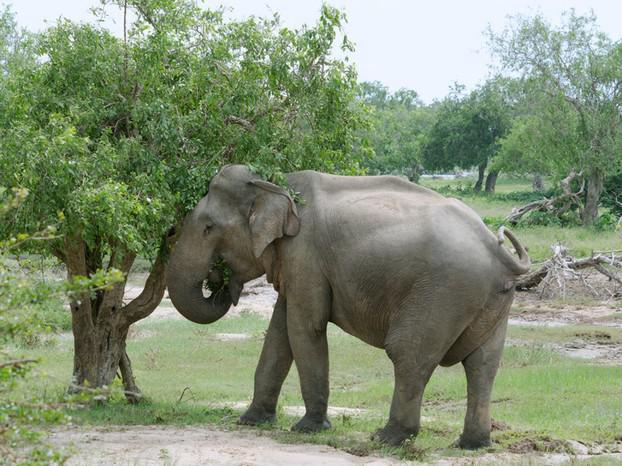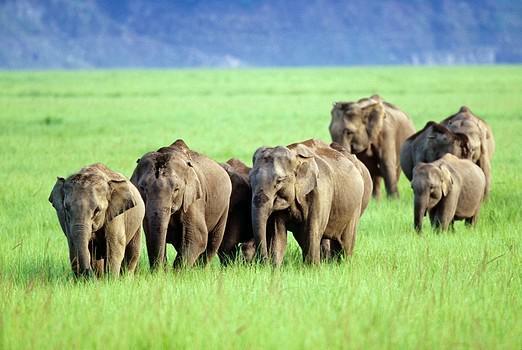The first image is the image on the left, the second image is the image on the right. For the images displayed, is the sentence "The animals in the image on the left are standing in the water." factually correct? Answer yes or no. No. 